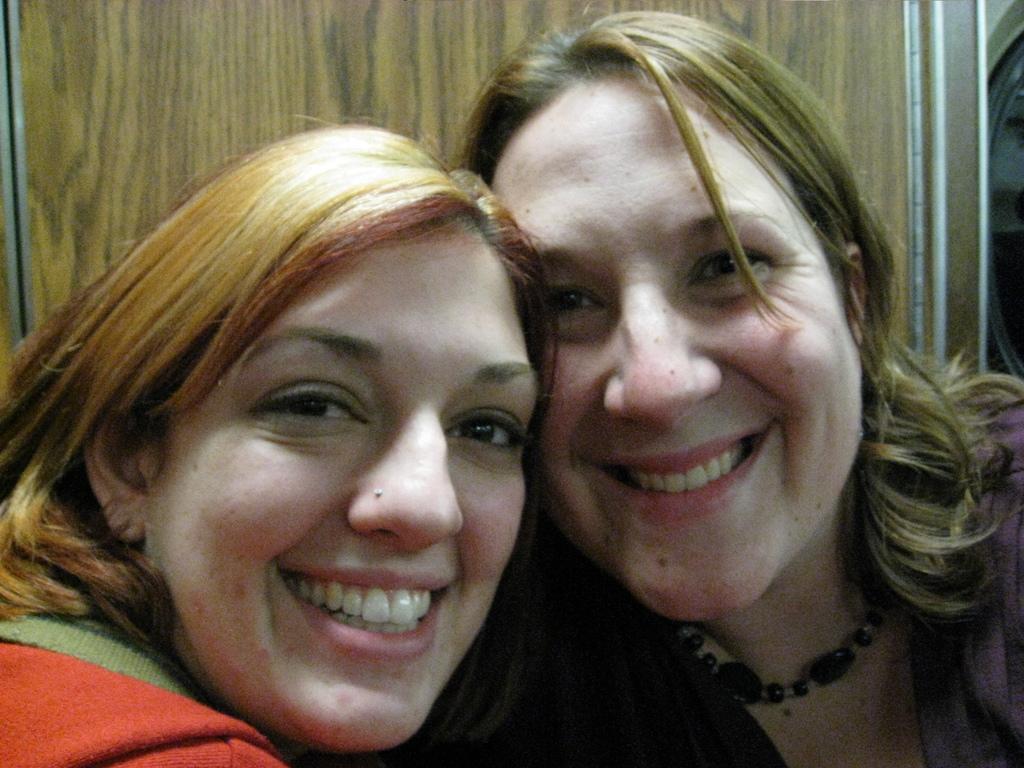In one or two sentences, can you explain what this image depicts? In this image, I can see two women smiling. This looks like a wooden board. 